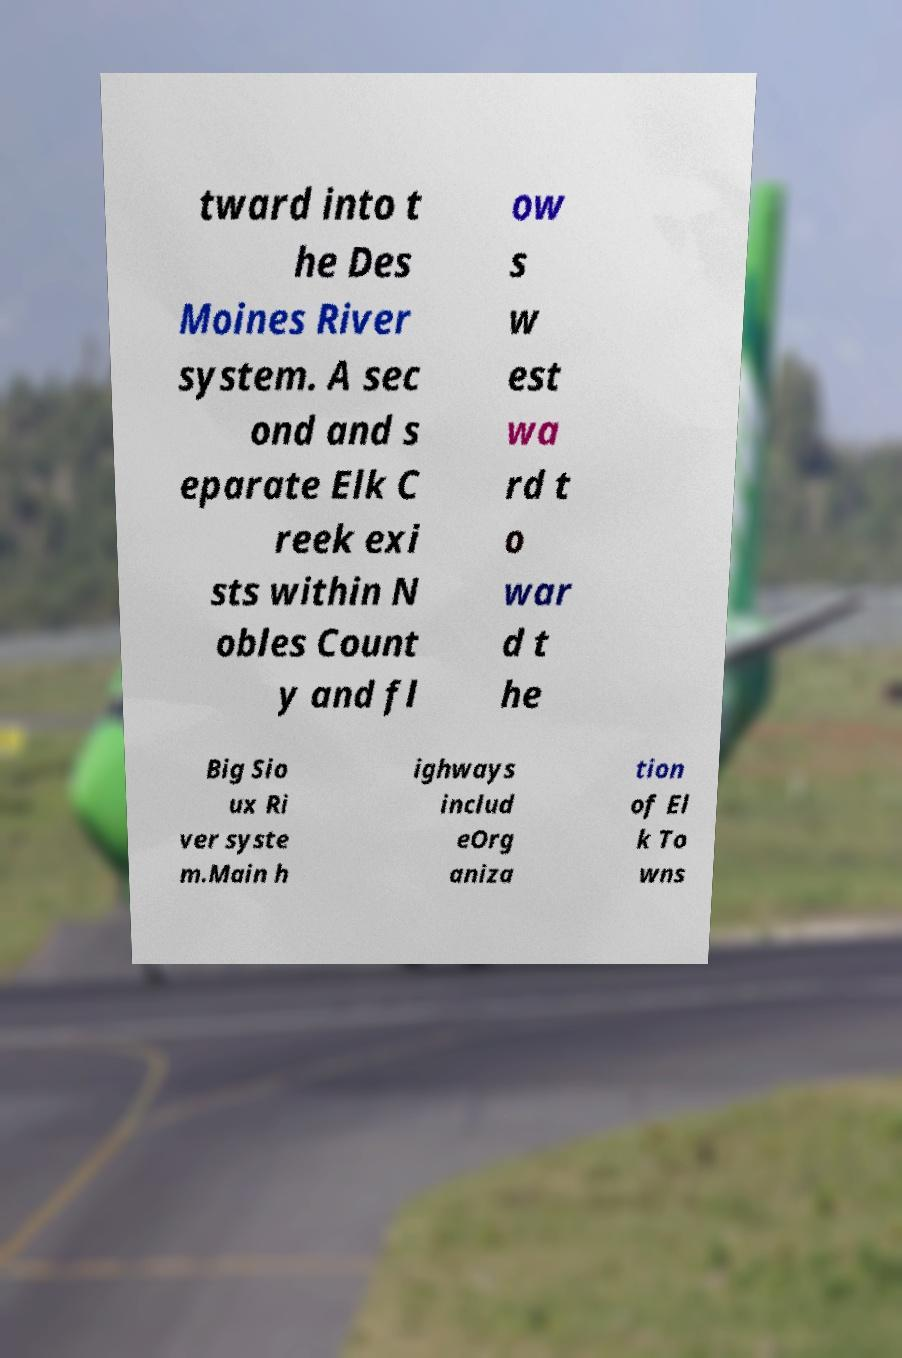Can you read and provide the text displayed in the image?This photo seems to have some interesting text. Can you extract and type it out for me? tward into t he Des Moines River system. A sec ond and s eparate Elk C reek exi sts within N obles Count y and fl ow s w est wa rd t o war d t he Big Sio ux Ri ver syste m.Main h ighways includ eOrg aniza tion of El k To wns 